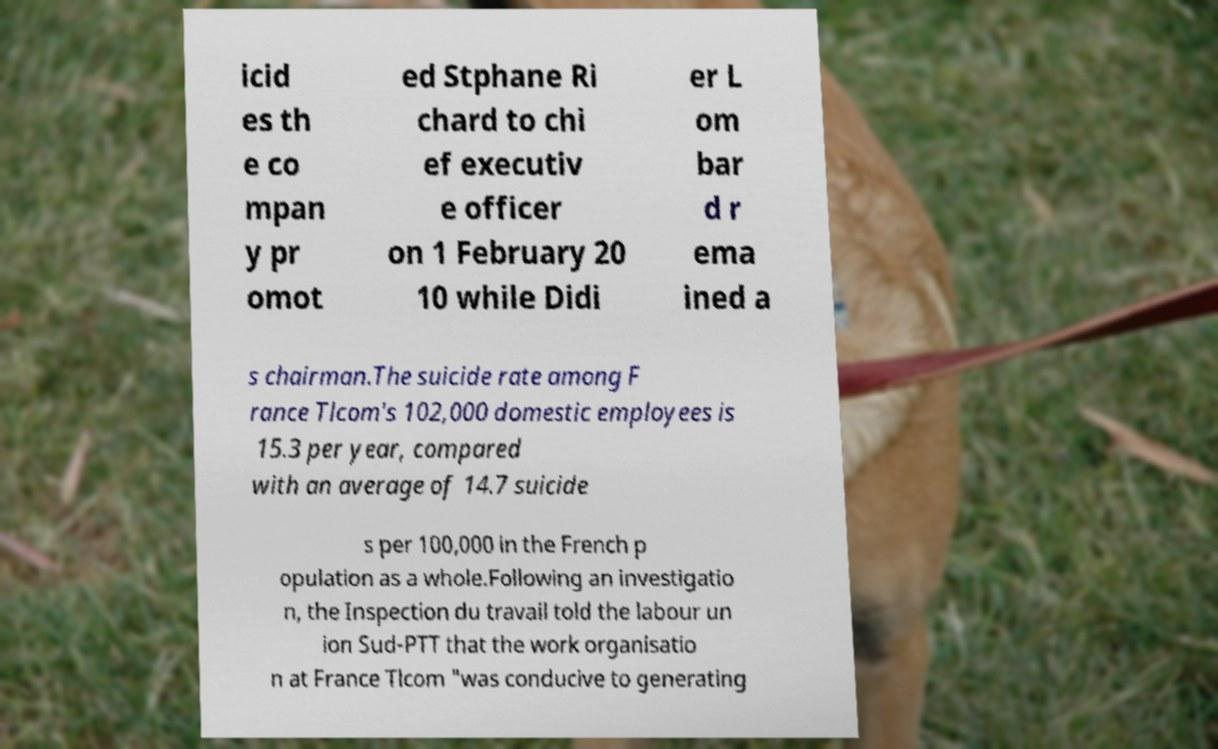There's text embedded in this image that I need extracted. Can you transcribe it verbatim? icid es th e co mpan y pr omot ed Stphane Ri chard to chi ef executiv e officer on 1 February 20 10 while Didi er L om bar d r ema ined a s chairman.The suicide rate among F rance Tlcom's 102,000 domestic employees is 15.3 per year, compared with an average of 14.7 suicide s per 100,000 in the French p opulation as a whole.Following an investigatio n, the Inspection du travail told the labour un ion Sud-PTT that the work organisatio n at France Tlcom "was conducive to generating 